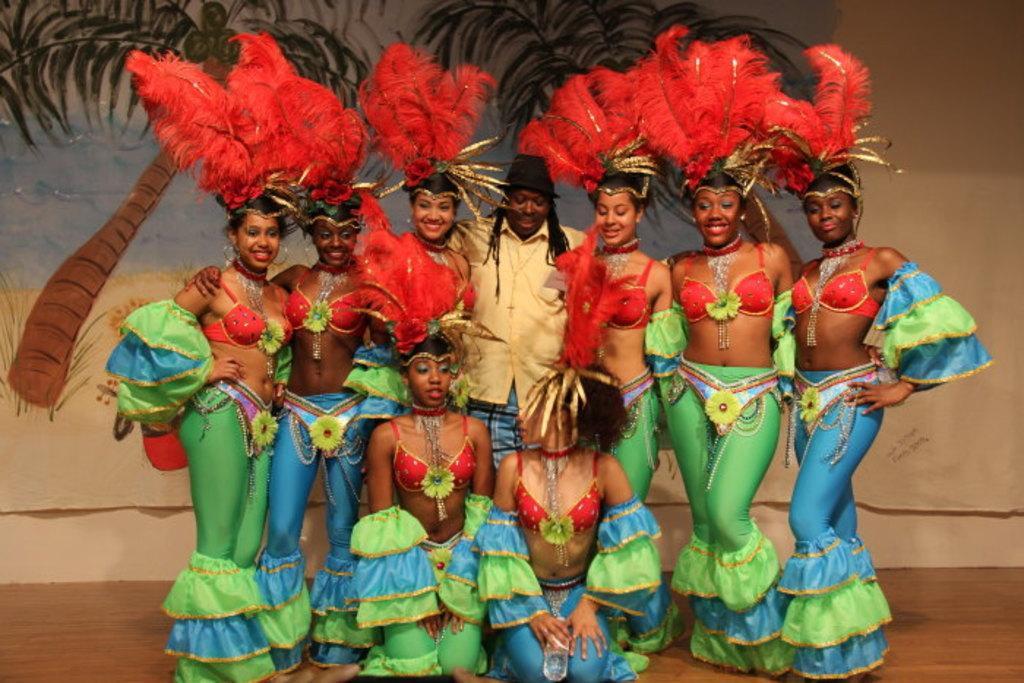Please provide a concise description of this image. In this image, I can see few people standing and two people sitting on the knees. I can see the woman with the fancy dresses. In the background, that looks like a painting on the cloth. At the bottom of the image, that looks like a wooden floor. 